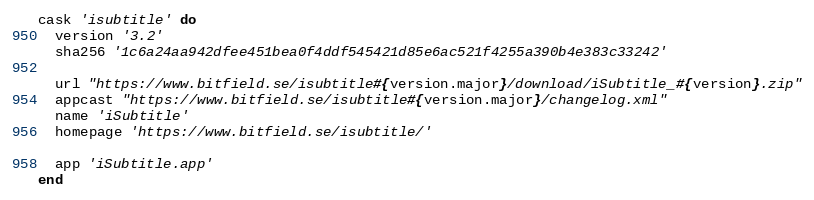<code> <loc_0><loc_0><loc_500><loc_500><_Ruby_>cask 'isubtitle' do
  version '3.2'
  sha256 '1c6a24aa942dfee451bea0f4ddf545421d85e6ac521f4255a390b4e383c33242'

  url "https://www.bitfield.se/isubtitle#{version.major}/download/iSubtitle_#{version}.zip"
  appcast "https://www.bitfield.se/isubtitle#{version.major}/changelog.xml"
  name 'iSubtitle'
  homepage 'https://www.bitfield.se/isubtitle/'

  app 'iSubtitle.app'
end
</code> 